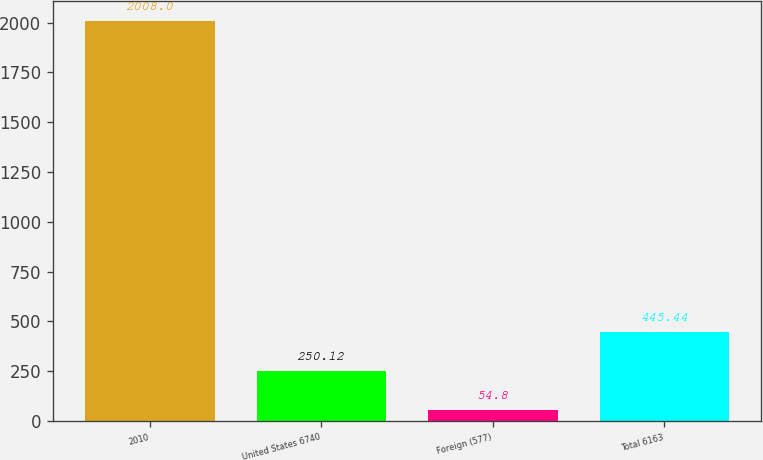<chart> <loc_0><loc_0><loc_500><loc_500><bar_chart><fcel>2010<fcel>United States 6740<fcel>Foreign (577)<fcel>Total 6163<nl><fcel>2008<fcel>250.12<fcel>54.8<fcel>445.44<nl></chart> 